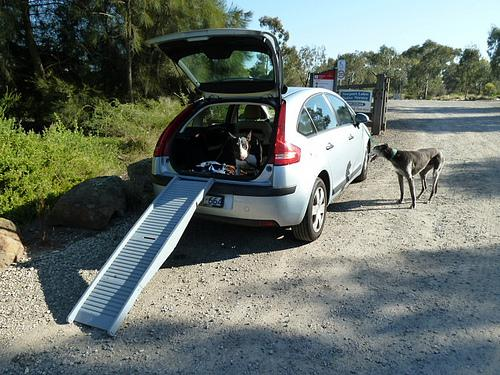Provide a brief description of the major elements in the image. A silver hatchback car with its rear door open, a dog inside and another dog standing beside, wooden signs, and the car parked on a gravel road near a green forest. Mention the car type and any distinctive features you see in the image. The car is a white hatchback with a raised door, a blue ramp extending out of the back, and a red taillight on the right side. Describe the image as if you were telling a story. On a scenic drive through a lush forest, a car stops on a gravel road so that the dogs inside could take a break, explore the surroundings, and maybe use the ramp to exit the vehicle. Mention the type of road and any features of the area surrounding the car. The car is parked on a gravel road, surrounded by rocks, shrubs, green grass, tall trees, and wooden signs. Provide a brief description of the activities or actions happening in the image. A car is parked with the hatch open, a dog is sitting inside, another dog is standing outside of the car, and there are wooden signs nearby. Describe the scene involving the dogs in the image. There's one dog sitting in the trunk of the open hatchback vehicle, while another dog with light green collar stands next to the car. List out the different animals and objects that you see in the image. Dogs, hatchback car, ramp, wooden signs, trees, rocks, and grass. In a single sentence, describe the setting of the image. A silver car with its hatch raised is parked near wooden signs on a grey gravel road, with dogs nearby and a green forest in the background. What interesting elements are present in the background of the image? In the background, there are tall green grass, a lush green forested area, various road signs posted on wooden posts, and a large rock. If you were a painter, what colors would you use to create this image? Greens for the grass and trees, silver for the car, blue for the ramp, white and black for the dogs, and various shades of gray for the road and some wooden elements. 